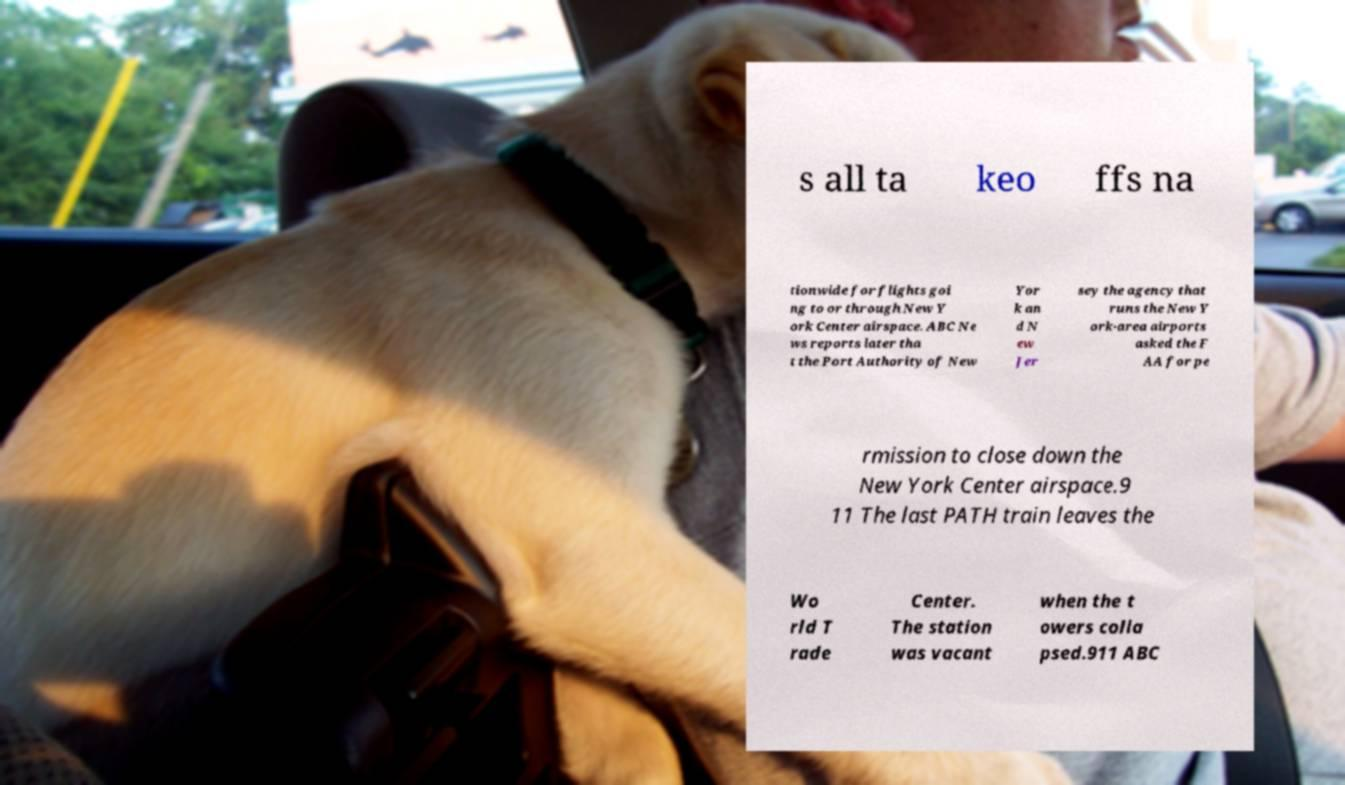For documentation purposes, I need the text within this image transcribed. Could you provide that? s all ta keo ffs na tionwide for flights goi ng to or through New Y ork Center airspace. ABC Ne ws reports later tha t the Port Authority of New Yor k an d N ew Jer sey the agency that runs the New Y ork-area airports asked the F AA for pe rmission to close down the New York Center airspace.9 11 The last PATH train leaves the Wo rld T rade Center. The station was vacant when the t owers colla psed.911 ABC 